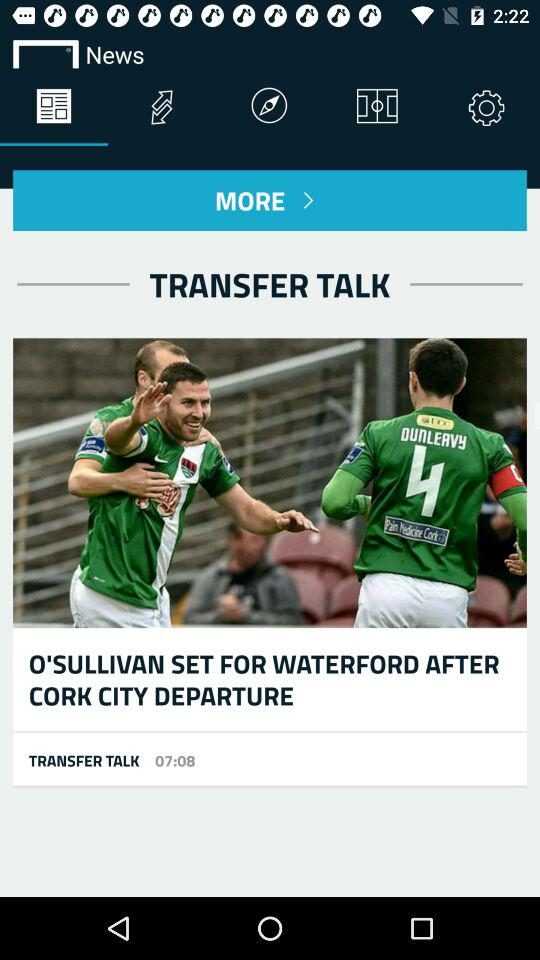How many minutes after 7:00 is the time shown in the screenshot?
Answer the question using a single word or phrase. 8 